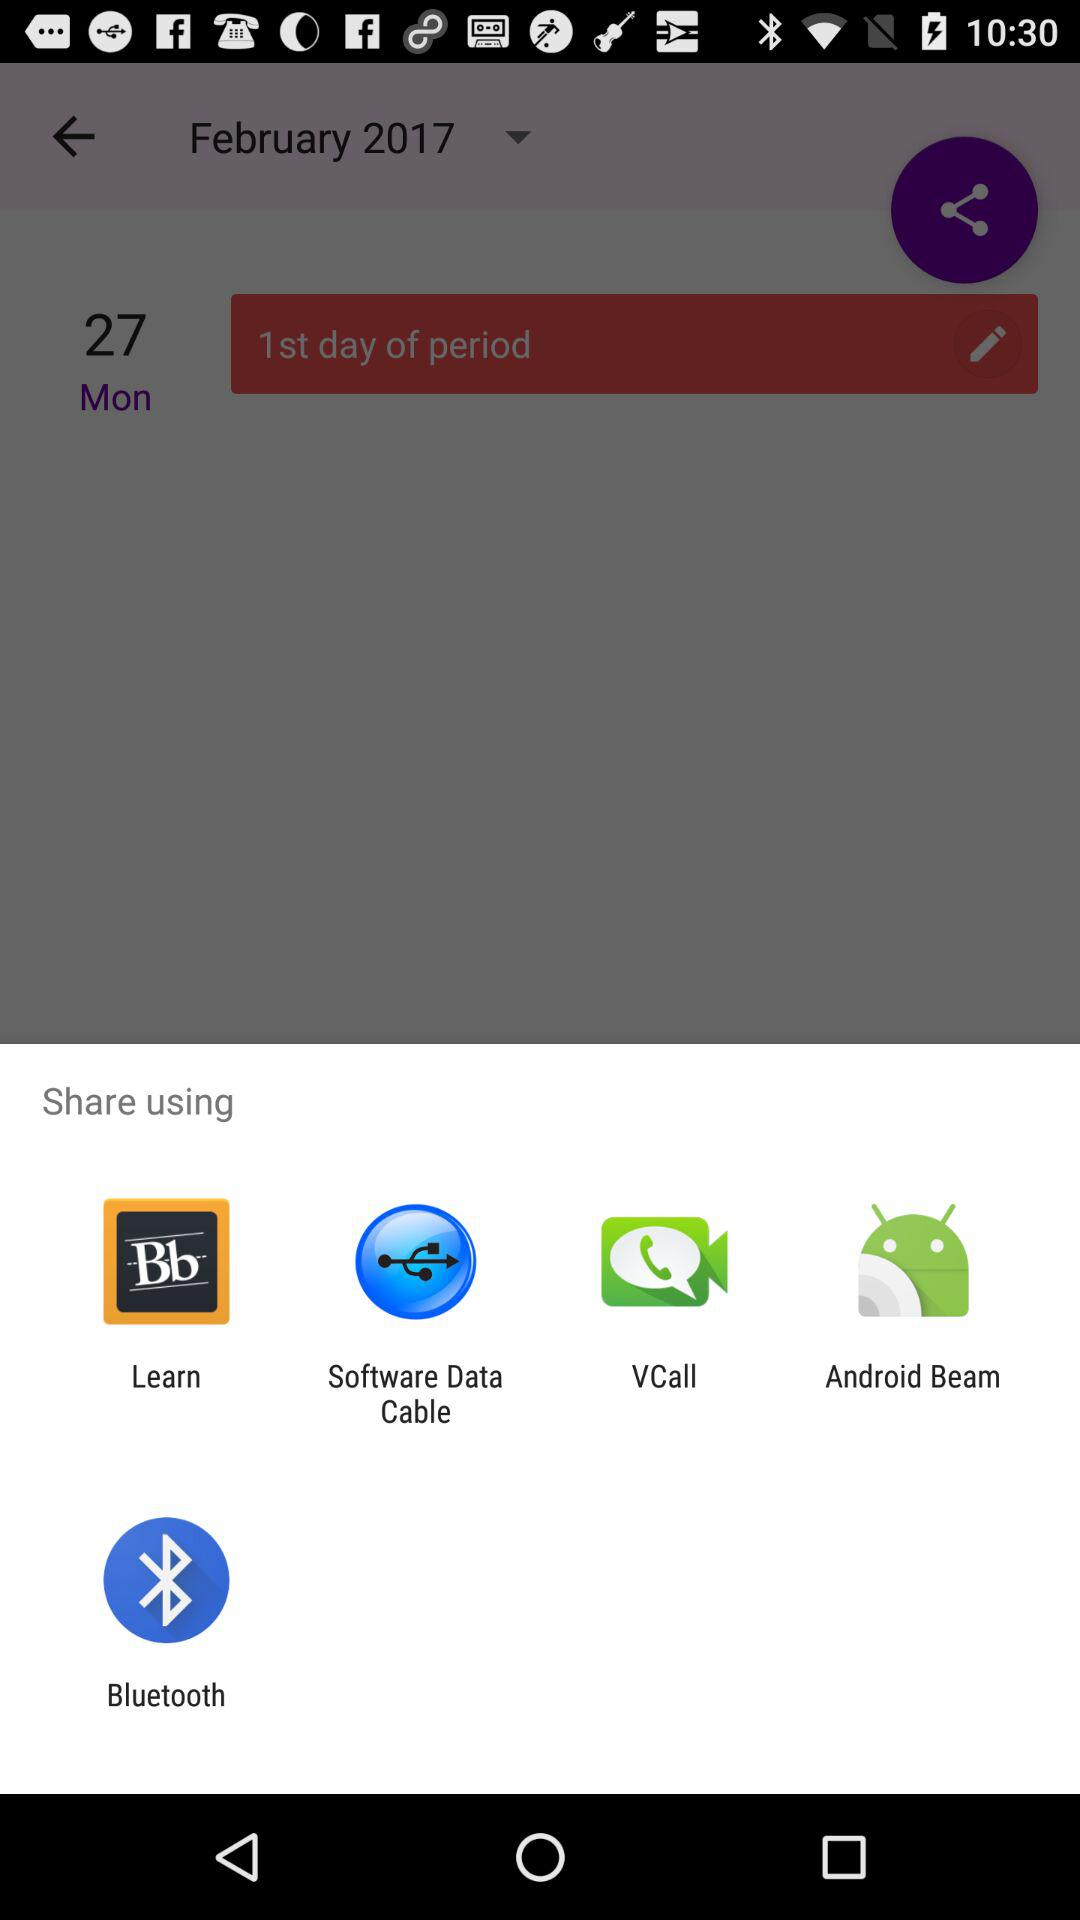What applications are used for sharing? The applications that are used for sharing are: "Learn", "Software Data Cable", "VCall", "Android Beam", and "Bluetooth". 